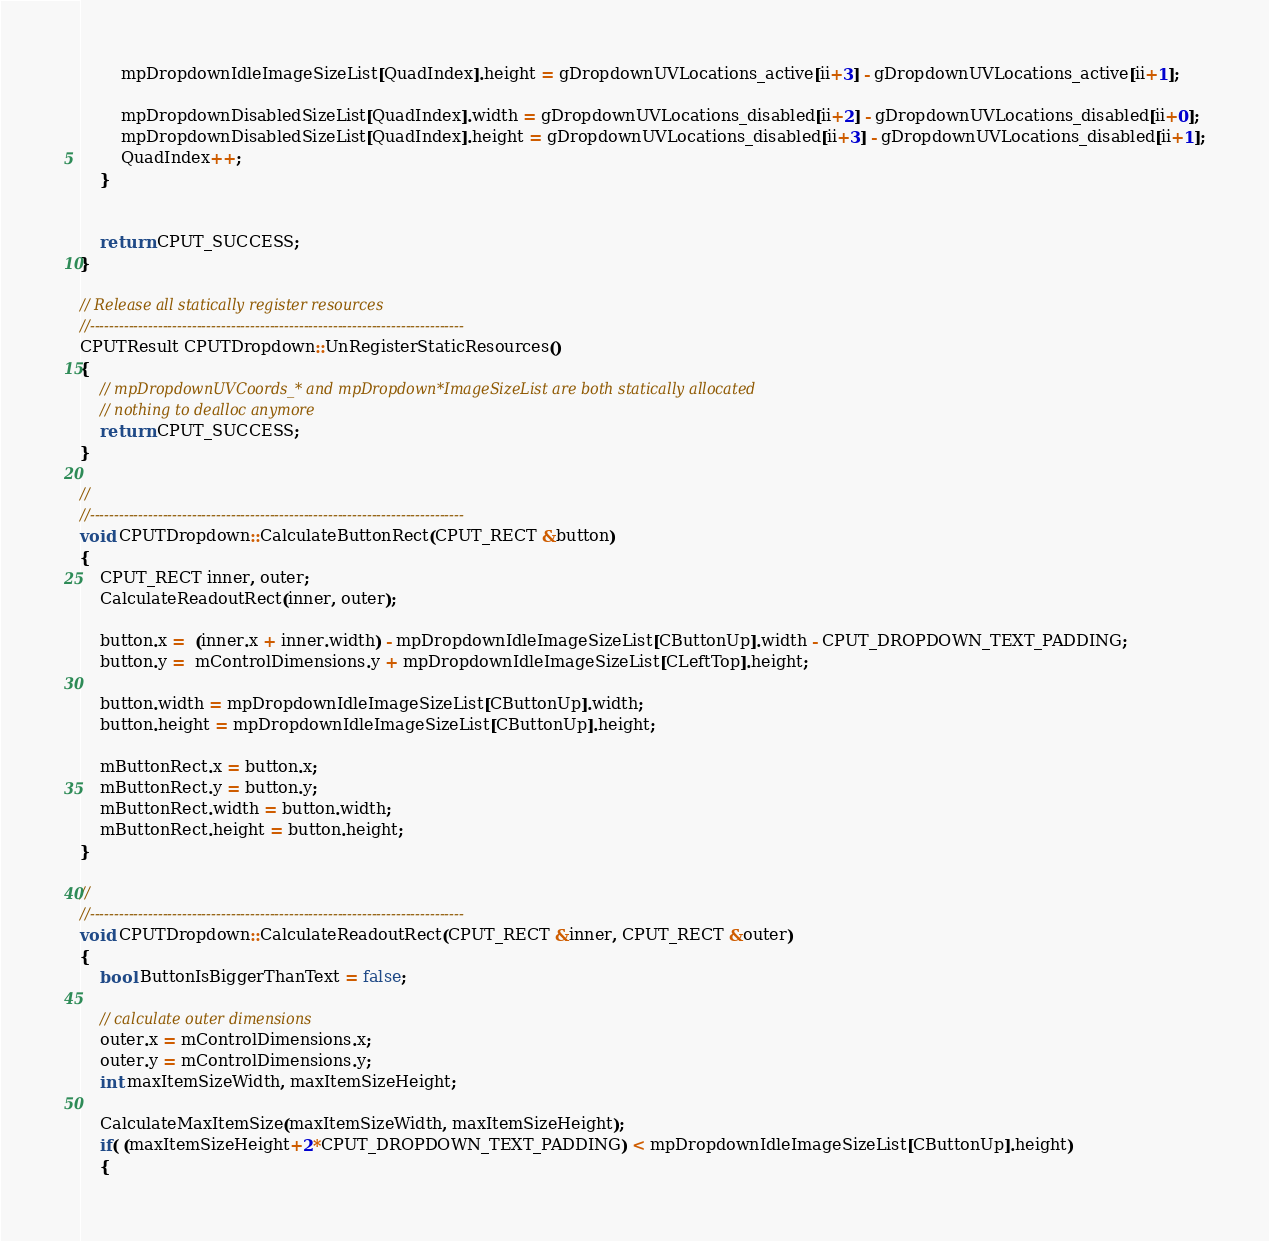Convert code to text. <code><loc_0><loc_0><loc_500><loc_500><_C++_>        mpDropdownIdleImageSizeList[QuadIndex].height = gDropdownUVLocations_active[ii+3] - gDropdownUVLocations_active[ii+1];

        mpDropdownDisabledSizeList[QuadIndex].width = gDropdownUVLocations_disabled[ii+2] - gDropdownUVLocations_disabled[ii+0];
        mpDropdownDisabledSizeList[QuadIndex].height = gDropdownUVLocations_disabled[ii+3] - gDropdownUVLocations_disabled[ii+1];
        QuadIndex++;
    }


    return CPUT_SUCCESS;
}

// Release all statically register resources
//-----------------------------------------------------------------------------
CPUTResult CPUTDropdown::UnRegisterStaticResources()
{
    // mpDropdownUVCoords_* and mpDropdown*ImageSizeList are both statically allocated
    // nothing to dealloc anymore
    return CPUT_SUCCESS;
}

//
//-----------------------------------------------------------------------------
void CPUTDropdown::CalculateButtonRect(CPUT_RECT &button)
{
    CPUT_RECT inner, outer;
    CalculateReadoutRect(inner, outer);

    button.x =  (inner.x + inner.width) - mpDropdownIdleImageSizeList[CButtonUp].width - CPUT_DROPDOWN_TEXT_PADDING;
    button.y =  mControlDimensions.y + mpDropdownIdleImageSizeList[CLeftTop].height;

    button.width = mpDropdownIdleImageSizeList[CButtonUp].width;
    button.height = mpDropdownIdleImageSizeList[CButtonUp].height;

    mButtonRect.x = button.x;
    mButtonRect.y = button.y;
    mButtonRect.width = button.width;
    mButtonRect.height = button.height;
}

//
//-----------------------------------------------------------------------------
void CPUTDropdown::CalculateReadoutRect(CPUT_RECT &inner, CPUT_RECT &outer)
{
    bool ButtonIsBiggerThanText = false;

    // calculate outer dimensions
    outer.x = mControlDimensions.x;
    outer.y = mControlDimensions.y;
    int maxItemSizeWidth, maxItemSizeHeight;

    CalculateMaxItemSize(maxItemSizeWidth, maxItemSizeHeight);
    if( (maxItemSizeHeight+2*CPUT_DROPDOWN_TEXT_PADDING) < mpDropdownIdleImageSizeList[CButtonUp].height)
    {</code> 